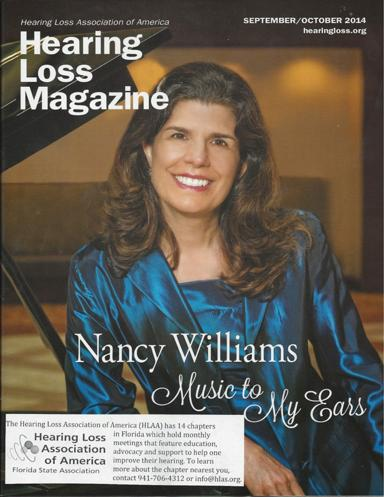How can one get more information about a chapter nearest to their location? For anyone interested in connecting with a nearby HLAA chapter, they can reach out directly by calling at 941-706-4312 or sending an email to info@hlas.org for detailed information and chapter activities. 